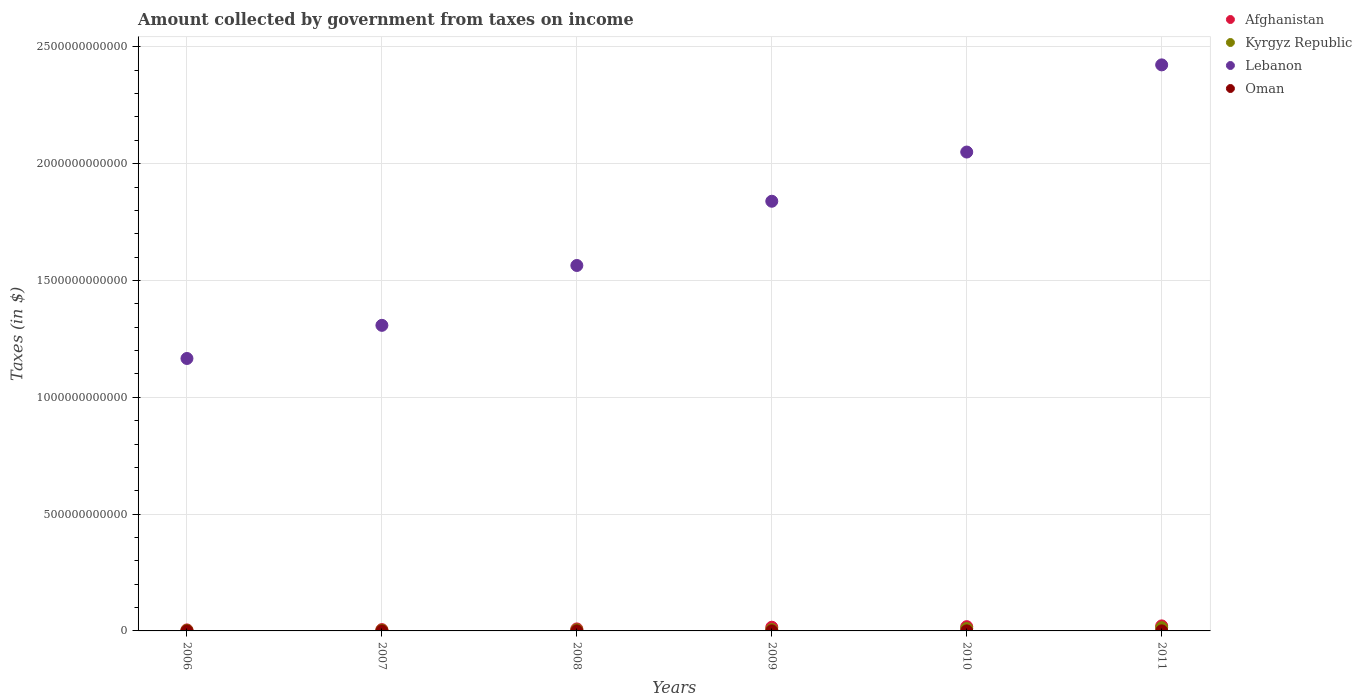How many different coloured dotlines are there?
Ensure brevity in your answer.  4. Is the number of dotlines equal to the number of legend labels?
Keep it short and to the point. Yes. What is the amount collected by government from taxes on income in Lebanon in 2006?
Ensure brevity in your answer.  1.17e+12. Across all years, what is the maximum amount collected by government from taxes on income in Oman?
Provide a short and direct response. 3.70e+08. Across all years, what is the minimum amount collected by government from taxes on income in Kyrgyz Republic?
Provide a succinct answer. 2.28e+09. In which year was the amount collected by government from taxes on income in Lebanon maximum?
Offer a very short reply. 2011. What is the total amount collected by government from taxes on income in Lebanon in the graph?
Offer a terse response. 1.04e+13. What is the difference between the amount collected by government from taxes on income in Afghanistan in 2009 and that in 2011?
Provide a short and direct response. -5.68e+09. What is the difference between the amount collected by government from taxes on income in Lebanon in 2010 and the amount collected by government from taxes on income in Kyrgyz Republic in 2009?
Ensure brevity in your answer.  2.04e+12. What is the average amount collected by government from taxes on income in Oman per year?
Offer a very short reply. 2.39e+08. In the year 2008, what is the difference between the amount collected by government from taxes on income in Kyrgyz Republic and amount collected by government from taxes on income in Lebanon?
Give a very brief answer. -1.56e+12. In how many years, is the amount collected by government from taxes on income in Afghanistan greater than 700000000000 $?
Your response must be concise. 0. What is the ratio of the amount collected by government from taxes on income in Oman in 2006 to that in 2011?
Provide a succinct answer. 0.3. Is the amount collected by government from taxes on income in Lebanon in 2006 less than that in 2011?
Provide a short and direct response. Yes. Is the difference between the amount collected by government from taxes on income in Kyrgyz Republic in 2007 and 2010 greater than the difference between the amount collected by government from taxes on income in Lebanon in 2007 and 2010?
Offer a very short reply. Yes. What is the difference between the highest and the second highest amount collected by government from taxes on income in Lebanon?
Keep it short and to the point. 3.73e+11. What is the difference between the highest and the lowest amount collected by government from taxes on income in Lebanon?
Make the answer very short. 1.26e+12. Is it the case that in every year, the sum of the amount collected by government from taxes on income in Lebanon and amount collected by government from taxes on income in Afghanistan  is greater than the sum of amount collected by government from taxes on income in Oman and amount collected by government from taxes on income in Kyrgyz Republic?
Your answer should be compact. No. Is it the case that in every year, the sum of the amount collected by government from taxes on income in Oman and amount collected by government from taxes on income in Kyrgyz Republic  is greater than the amount collected by government from taxes on income in Afghanistan?
Make the answer very short. No. Is the amount collected by government from taxes on income in Afghanistan strictly greater than the amount collected by government from taxes on income in Oman over the years?
Your response must be concise. Yes. How many dotlines are there?
Ensure brevity in your answer.  4. What is the difference between two consecutive major ticks on the Y-axis?
Offer a very short reply. 5.00e+11. How many legend labels are there?
Provide a succinct answer. 4. What is the title of the graph?
Offer a terse response. Amount collected by government from taxes on income. Does "Monaco" appear as one of the legend labels in the graph?
Provide a short and direct response. No. What is the label or title of the X-axis?
Your answer should be compact. Years. What is the label or title of the Y-axis?
Provide a short and direct response. Taxes (in $). What is the Taxes (in $) of Afghanistan in 2006?
Give a very brief answer. 4.36e+09. What is the Taxes (in $) of Kyrgyz Republic in 2006?
Give a very brief answer. 2.28e+09. What is the Taxes (in $) of Lebanon in 2006?
Give a very brief answer. 1.17e+12. What is the Taxes (in $) in Oman in 2006?
Make the answer very short. 8.54e+07. What is the Taxes (in $) in Afghanistan in 2007?
Make the answer very short. 5.64e+09. What is the Taxes (in $) in Kyrgyz Republic in 2007?
Offer a very short reply. 3.04e+09. What is the Taxes (in $) of Lebanon in 2007?
Provide a succinct answer. 1.31e+12. What is the Taxes (in $) in Oman in 2007?
Your answer should be compact. 1.87e+08. What is the Taxes (in $) of Afghanistan in 2008?
Your answer should be very brief. 8.62e+09. What is the Taxes (in $) of Kyrgyz Republic in 2008?
Make the answer very short. 4.61e+09. What is the Taxes (in $) in Lebanon in 2008?
Make the answer very short. 1.56e+12. What is the Taxes (in $) of Oman in 2008?
Ensure brevity in your answer.  2.37e+08. What is the Taxes (in $) of Afghanistan in 2009?
Ensure brevity in your answer.  1.58e+1. What is the Taxes (in $) in Kyrgyz Republic in 2009?
Offer a terse response. 5.75e+09. What is the Taxes (in $) in Lebanon in 2009?
Your answer should be very brief. 1.84e+12. What is the Taxes (in $) of Oman in 2009?
Provide a succinct answer. 3.70e+08. What is the Taxes (in $) in Afghanistan in 2010?
Your answer should be very brief. 1.82e+1. What is the Taxes (in $) in Kyrgyz Republic in 2010?
Your response must be concise. 1.04e+1. What is the Taxes (in $) of Lebanon in 2010?
Give a very brief answer. 2.05e+12. What is the Taxes (in $) in Oman in 2010?
Your answer should be compact. 2.73e+08. What is the Taxes (in $) of Afghanistan in 2011?
Provide a succinct answer. 2.15e+1. What is the Taxes (in $) of Kyrgyz Republic in 2011?
Keep it short and to the point. 1.40e+1. What is the Taxes (in $) in Lebanon in 2011?
Offer a terse response. 2.42e+12. What is the Taxes (in $) of Oman in 2011?
Make the answer very short. 2.82e+08. Across all years, what is the maximum Taxes (in $) of Afghanistan?
Ensure brevity in your answer.  2.15e+1. Across all years, what is the maximum Taxes (in $) of Kyrgyz Republic?
Your response must be concise. 1.40e+1. Across all years, what is the maximum Taxes (in $) of Lebanon?
Give a very brief answer. 2.42e+12. Across all years, what is the maximum Taxes (in $) of Oman?
Provide a succinct answer. 3.70e+08. Across all years, what is the minimum Taxes (in $) in Afghanistan?
Offer a very short reply. 4.36e+09. Across all years, what is the minimum Taxes (in $) of Kyrgyz Republic?
Offer a terse response. 2.28e+09. Across all years, what is the minimum Taxes (in $) in Lebanon?
Provide a short and direct response. 1.17e+12. Across all years, what is the minimum Taxes (in $) of Oman?
Give a very brief answer. 8.54e+07. What is the total Taxes (in $) in Afghanistan in the graph?
Make the answer very short. 7.42e+1. What is the total Taxes (in $) in Kyrgyz Republic in the graph?
Ensure brevity in your answer.  4.01e+1. What is the total Taxes (in $) of Lebanon in the graph?
Offer a terse response. 1.04e+13. What is the total Taxes (in $) in Oman in the graph?
Keep it short and to the point. 1.43e+09. What is the difference between the Taxes (in $) of Afghanistan in 2006 and that in 2007?
Your response must be concise. -1.28e+09. What is the difference between the Taxes (in $) in Kyrgyz Republic in 2006 and that in 2007?
Give a very brief answer. -7.61e+08. What is the difference between the Taxes (in $) in Lebanon in 2006 and that in 2007?
Make the answer very short. -1.42e+11. What is the difference between the Taxes (in $) of Oman in 2006 and that in 2007?
Provide a succinct answer. -1.02e+08. What is the difference between the Taxes (in $) of Afghanistan in 2006 and that in 2008?
Offer a very short reply. -4.25e+09. What is the difference between the Taxes (in $) of Kyrgyz Republic in 2006 and that in 2008?
Provide a short and direct response. -2.34e+09. What is the difference between the Taxes (in $) in Lebanon in 2006 and that in 2008?
Your answer should be compact. -3.98e+11. What is the difference between the Taxes (in $) of Oman in 2006 and that in 2008?
Your answer should be compact. -1.52e+08. What is the difference between the Taxes (in $) of Afghanistan in 2006 and that in 2009?
Ensure brevity in your answer.  -1.15e+1. What is the difference between the Taxes (in $) of Kyrgyz Republic in 2006 and that in 2009?
Keep it short and to the point. -3.47e+09. What is the difference between the Taxes (in $) in Lebanon in 2006 and that in 2009?
Provide a short and direct response. -6.73e+11. What is the difference between the Taxes (in $) of Oman in 2006 and that in 2009?
Provide a short and direct response. -2.85e+08. What is the difference between the Taxes (in $) of Afghanistan in 2006 and that in 2010?
Provide a succinct answer. -1.39e+1. What is the difference between the Taxes (in $) in Kyrgyz Republic in 2006 and that in 2010?
Make the answer very short. -8.11e+09. What is the difference between the Taxes (in $) of Lebanon in 2006 and that in 2010?
Your response must be concise. -8.84e+11. What is the difference between the Taxes (in $) of Oman in 2006 and that in 2010?
Ensure brevity in your answer.  -1.87e+08. What is the difference between the Taxes (in $) in Afghanistan in 2006 and that in 2011?
Offer a very short reply. -1.72e+1. What is the difference between the Taxes (in $) in Kyrgyz Republic in 2006 and that in 2011?
Give a very brief answer. -1.17e+1. What is the difference between the Taxes (in $) in Lebanon in 2006 and that in 2011?
Provide a short and direct response. -1.26e+12. What is the difference between the Taxes (in $) in Oman in 2006 and that in 2011?
Offer a terse response. -1.96e+08. What is the difference between the Taxes (in $) in Afghanistan in 2007 and that in 2008?
Give a very brief answer. -2.97e+09. What is the difference between the Taxes (in $) of Kyrgyz Republic in 2007 and that in 2008?
Your answer should be very brief. -1.57e+09. What is the difference between the Taxes (in $) of Lebanon in 2007 and that in 2008?
Provide a succinct answer. -2.56e+11. What is the difference between the Taxes (in $) of Oman in 2007 and that in 2008?
Your response must be concise. -5.03e+07. What is the difference between the Taxes (in $) of Afghanistan in 2007 and that in 2009?
Your answer should be very brief. -1.02e+1. What is the difference between the Taxes (in $) in Kyrgyz Republic in 2007 and that in 2009?
Make the answer very short. -2.71e+09. What is the difference between the Taxes (in $) in Lebanon in 2007 and that in 2009?
Keep it short and to the point. -5.31e+11. What is the difference between the Taxes (in $) of Oman in 2007 and that in 2009?
Provide a succinct answer. -1.83e+08. What is the difference between the Taxes (in $) of Afghanistan in 2007 and that in 2010?
Your response must be concise. -1.26e+1. What is the difference between the Taxes (in $) of Kyrgyz Republic in 2007 and that in 2010?
Your answer should be compact. -7.35e+09. What is the difference between the Taxes (in $) in Lebanon in 2007 and that in 2010?
Keep it short and to the point. -7.42e+11. What is the difference between the Taxes (in $) of Oman in 2007 and that in 2010?
Provide a short and direct response. -8.55e+07. What is the difference between the Taxes (in $) of Afghanistan in 2007 and that in 2011?
Keep it short and to the point. -1.59e+1. What is the difference between the Taxes (in $) of Kyrgyz Republic in 2007 and that in 2011?
Ensure brevity in your answer.  -1.09e+1. What is the difference between the Taxes (in $) of Lebanon in 2007 and that in 2011?
Your response must be concise. -1.11e+12. What is the difference between the Taxes (in $) of Oman in 2007 and that in 2011?
Keep it short and to the point. -9.48e+07. What is the difference between the Taxes (in $) in Afghanistan in 2008 and that in 2009?
Keep it short and to the point. -7.23e+09. What is the difference between the Taxes (in $) of Kyrgyz Republic in 2008 and that in 2009?
Provide a short and direct response. -1.14e+09. What is the difference between the Taxes (in $) in Lebanon in 2008 and that in 2009?
Give a very brief answer. -2.75e+11. What is the difference between the Taxes (in $) in Oman in 2008 and that in 2009?
Offer a terse response. -1.33e+08. What is the difference between the Taxes (in $) in Afghanistan in 2008 and that in 2010?
Offer a very short reply. -9.63e+09. What is the difference between the Taxes (in $) of Kyrgyz Republic in 2008 and that in 2010?
Your answer should be very brief. -5.77e+09. What is the difference between the Taxes (in $) in Lebanon in 2008 and that in 2010?
Offer a very short reply. -4.86e+11. What is the difference between the Taxes (in $) in Oman in 2008 and that in 2010?
Provide a short and direct response. -3.52e+07. What is the difference between the Taxes (in $) of Afghanistan in 2008 and that in 2011?
Provide a short and direct response. -1.29e+1. What is the difference between the Taxes (in $) in Kyrgyz Republic in 2008 and that in 2011?
Keep it short and to the point. -9.36e+09. What is the difference between the Taxes (in $) of Lebanon in 2008 and that in 2011?
Keep it short and to the point. -8.59e+11. What is the difference between the Taxes (in $) in Oman in 2008 and that in 2011?
Ensure brevity in your answer.  -4.45e+07. What is the difference between the Taxes (in $) of Afghanistan in 2009 and that in 2010?
Offer a very short reply. -2.41e+09. What is the difference between the Taxes (in $) in Kyrgyz Republic in 2009 and that in 2010?
Offer a terse response. -4.63e+09. What is the difference between the Taxes (in $) in Lebanon in 2009 and that in 2010?
Provide a short and direct response. -2.11e+11. What is the difference between the Taxes (in $) of Oman in 2009 and that in 2010?
Give a very brief answer. 9.75e+07. What is the difference between the Taxes (in $) of Afghanistan in 2009 and that in 2011?
Your answer should be very brief. -5.68e+09. What is the difference between the Taxes (in $) in Kyrgyz Republic in 2009 and that in 2011?
Your answer should be very brief. -8.23e+09. What is the difference between the Taxes (in $) of Lebanon in 2009 and that in 2011?
Make the answer very short. -5.84e+11. What is the difference between the Taxes (in $) of Oman in 2009 and that in 2011?
Offer a very short reply. 8.82e+07. What is the difference between the Taxes (in $) of Afghanistan in 2010 and that in 2011?
Ensure brevity in your answer.  -3.27e+09. What is the difference between the Taxes (in $) of Kyrgyz Republic in 2010 and that in 2011?
Provide a succinct answer. -3.59e+09. What is the difference between the Taxes (in $) in Lebanon in 2010 and that in 2011?
Give a very brief answer. -3.73e+11. What is the difference between the Taxes (in $) in Oman in 2010 and that in 2011?
Offer a terse response. -9.30e+06. What is the difference between the Taxes (in $) of Afghanistan in 2006 and the Taxes (in $) of Kyrgyz Republic in 2007?
Offer a terse response. 1.32e+09. What is the difference between the Taxes (in $) in Afghanistan in 2006 and the Taxes (in $) in Lebanon in 2007?
Keep it short and to the point. -1.30e+12. What is the difference between the Taxes (in $) in Afghanistan in 2006 and the Taxes (in $) in Oman in 2007?
Your answer should be compact. 4.17e+09. What is the difference between the Taxes (in $) of Kyrgyz Republic in 2006 and the Taxes (in $) of Lebanon in 2007?
Offer a very short reply. -1.31e+12. What is the difference between the Taxes (in $) of Kyrgyz Republic in 2006 and the Taxes (in $) of Oman in 2007?
Provide a succinct answer. 2.09e+09. What is the difference between the Taxes (in $) in Lebanon in 2006 and the Taxes (in $) in Oman in 2007?
Keep it short and to the point. 1.17e+12. What is the difference between the Taxes (in $) of Afghanistan in 2006 and the Taxes (in $) of Kyrgyz Republic in 2008?
Offer a very short reply. -2.54e+08. What is the difference between the Taxes (in $) in Afghanistan in 2006 and the Taxes (in $) in Lebanon in 2008?
Provide a succinct answer. -1.56e+12. What is the difference between the Taxes (in $) in Afghanistan in 2006 and the Taxes (in $) in Oman in 2008?
Offer a terse response. 4.12e+09. What is the difference between the Taxes (in $) in Kyrgyz Republic in 2006 and the Taxes (in $) in Lebanon in 2008?
Offer a terse response. -1.56e+12. What is the difference between the Taxes (in $) of Kyrgyz Republic in 2006 and the Taxes (in $) of Oman in 2008?
Your answer should be compact. 2.04e+09. What is the difference between the Taxes (in $) in Lebanon in 2006 and the Taxes (in $) in Oman in 2008?
Your answer should be very brief. 1.17e+12. What is the difference between the Taxes (in $) in Afghanistan in 2006 and the Taxes (in $) in Kyrgyz Republic in 2009?
Provide a short and direct response. -1.39e+09. What is the difference between the Taxes (in $) of Afghanistan in 2006 and the Taxes (in $) of Lebanon in 2009?
Keep it short and to the point. -1.83e+12. What is the difference between the Taxes (in $) in Afghanistan in 2006 and the Taxes (in $) in Oman in 2009?
Keep it short and to the point. 3.99e+09. What is the difference between the Taxes (in $) in Kyrgyz Republic in 2006 and the Taxes (in $) in Lebanon in 2009?
Provide a short and direct response. -1.84e+12. What is the difference between the Taxes (in $) in Kyrgyz Republic in 2006 and the Taxes (in $) in Oman in 2009?
Your response must be concise. 1.91e+09. What is the difference between the Taxes (in $) of Lebanon in 2006 and the Taxes (in $) of Oman in 2009?
Offer a terse response. 1.17e+12. What is the difference between the Taxes (in $) of Afghanistan in 2006 and the Taxes (in $) of Kyrgyz Republic in 2010?
Offer a very short reply. -6.02e+09. What is the difference between the Taxes (in $) in Afghanistan in 2006 and the Taxes (in $) in Lebanon in 2010?
Your answer should be very brief. -2.05e+12. What is the difference between the Taxes (in $) in Afghanistan in 2006 and the Taxes (in $) in Oman in 2010?
Ensure brevity in your answer.  4.09e+09. What is the difference between the Taxes (in $) of Kyrgyz Republic in 2006 and the Taxes (in $) of Lebanon in 2010?
Give a very brief answer. -2.05e+12. What is the difference between the Taxes (in $) of Kyrgyz Republic in 2006 and the Taxes (in $) of Oman in 2010?
Ensure brevity in your answer.  2.01e+09. What is the difference between the Taxes (in $) in Lebanon in 2006 and the Taxes (in $) in Oman in 2010?
Your answer should be very brief. 1.17e+12. What is the difference between the Taxes (in $) in Afghanistan in 2006 and the Taxes (in $) in Kyrgyz Republic in 2011?
Keep it short and to the point. -9.62e+09. What is the difference between the Taxes (in $) in Afghanistan in 2006 and the Taxes (in $) in Lebanon in 2011?
Your answer should be very brief. -2.42e+12. What is the difference between the Taxes (in $) of Afghanistan in 2006 and the Taxes (in $) of Oman in 2011?
Keep it short and to the point. 4.08e+09. What is the difference between the Taxes (in $) of Kyrgyz Republic in 2006 and the Taxes (in $) of Lebanon in 2011?
Offer a very short reply. -2.42e+12. What is the difference between the Taxes (in $) in Kyrgyz Republic in 2006 and the Taxes (in $) in Oman in 2011?
Provide a succinct answer. 2.00e+09. What is the difference between the Taxes (in $) of Lebanon in 2006 and the Taxes (in $) of Oman in 2011?
Offer a terse response. 1.17e+12. What is the difference between the Taxes (in $) of Afghanistan in 2007 and the Taxes (in $) of Kyrgyz Republic in 2008?
Give a very brief answer. 1.03e+09. What is the difference between the Taxes (in $) of Afghanistan in 2007 and the Taxes (in $) of Lebanon in 2008?
Your answer should be compact. -1.56e+12. What is the difference between the Taxes (in $) of Afghanistan in 2007 and the Taxes (in $) of Oman in 2008?
Keep it short and to the point. 5.41e+09. What is the difference between the Taxes (in $) of Kyrgyz Republic in 2007 and the Taxes (in $) of Lebanon in 2008?
Provide a short and direct response. -1.56e+12. What is the difference between the Taxes (in $) of Kyrgyz Republic in 2007 and the Taxes (in $) of Oman in 2008?
Provide a succinct answer. 2.80e+09. What is the difference between the Taxes (in $) of Lebanon in 2007 and the Taxes (in $) of Oman in 2008?
Your response must be concise. 1.31e+12. What is the difference between the Taxes (in $) of Afghanistan in 2007 and the Taxes (in $) of Kyrgyz Republic in 2009?
Ensure brevity in your answer.  -1.07e+08. What is the difference between the Taxes (in $) of Afghanistan in 2007 and the Taxes (in $) of Lebanon in 2009?
Offer a terse response. -1.83e+12. What is the difference between the Taxes (in $) of Afghanistan in 2007 and the Taxes (in $) of Oman in 2009?
Your answer should be very brief. 5.27e+09. What is the difference between the Taxes (in $) in Kyrgyz Republic in 2007 and the Taxes (in $) in Lebanon in 2009?
Offer a very short reply. -1.84e+12. What is the difference between the Taxes (in $) in Kyrgyz Republic in 2007 and the Taxes (in $) in Oman in 2009?
Make the answer very short. 2.67e+09. What is the difference between the Taxes (in $) in Lebanon in 2007 and the Taxes (in $) in Oman in 2009?
Your answer should be very brief. 1.31e+12. What is the difference between the Taxes (in $) in Afghanistan in 2007 and the Taxes (in $) in Kyrgyz Republic in 2010?
Your response must be concise. -4.74e+09. What is the difference between the Taxes (in $) of Afghanistan in 2007 and the Taxes (in $) of Lebanon in 2010?
Offer a terse response. -2.04e+12. What is the difference between the Taxes (in $) in Afghanistan in 2007 and the Taxes (in $) in Oman in 2010?
Make the answer very short. 5.37e+09. What is the difference between the Taxes (in $) in Kyrgyz Republic in 2007 and the Taxes (in $) in Lebanon in 2010?
Give a very brief answer. -2.05e+12. What is the difference between the Taxes (in $) of Kyrgyz Republic in 2007 and the Taxes (in $) of Oman in 2010?
Your answer should be compact. 2.77e+09. What is the difference between the Taxes (in $) in Lebanon in 2007 and the Taxes (in $) in Oman in 2010?
Your response must be concise. 1.31e+12. What is the difference between the Taxes (in $) of Afghanistan in 2007 and the Taxes (in $) of Kyrgyz Republic in 2011?
Your response must be concise. -8.33e+09. What is the difference between the Taxes (in $) of Afghanistan in 2007 and the Taxes (in $) of Lebanon in 2011?
Your response must be concise. -2.42e+12. What is the difference between the Taxes (in $) in Afghanistan in 2007 and the Taxes (in $) in Oman in 2011?
Offer a very short reply. 5.36e+09. What is the difference between the Taxes (in $) in Kyrgyz Republic in 2007 and the Taxes (in $) in Lebanon in 2011?
Provide a succinct answer. -2.42e+12. What is the difference between the Taxes (in $) of Kyrgyz Republic in 2007 and the Taxes (in $) of Oman in 2011?
Offer a very short reply. 2.76e+09. What is the difference between the Taxes (in $) of Lebanon in 2007 and the Taxes (in $) of Oman in 2011?
Your response must be concise. 1.31e+12. What is the difference between the Taxes (in $) in Afghanistan in 2008 and the Taxes (in $) in Kyrgyz Republic in 2009?
Keep it short and to the point. 2.86e+09. What is the difference between the Taxes (in $) of Afghanistan in 2008 and the Taxes (in $) of Lebanon in 2009?
Offer a very short reply. -1.83e+12. What is the difference between the Taxes (in $) of Afghanistan in 2008 and the Taxes (in $) of Oman in 2009?
Offer a terse response. 8.24e+09. What is the difference between the Taxes (in $) in Kyrgyz Republic in 2008 and the Taxes (in $) in Lebanon in 2009?
Make the answer very short. -1.83e+12. What is the difference between the Taxes (in $) in Kyrgyz Republic in 2008 and the Taxes (in $) in Oman in 2009?
Your answer should be very brief. 4.24e+09. What is the difference between the Taxes (in $) in Lebanon in 2008 and the Taxes (in $) in Oman in 2009?
Make the answer very short. 1.56e+12. What is the difference between the Taxes (in $) of Afghanistan in 2008 and the Taxes (in $) of Kyrgyz Republic in 2010?
Make the answer very short. -1.77e+09. What is the difference between the Taxes (in $) in Afghanistan in 2008 and the Taxes (in $) in Lebanon in 2010?
Make the answer very short. -2.04e+12. What is the difference between the Taxes (in $) of Afghanistan in 2008 and the Taxes (in $) of Oman in 2010?
Keep it short and to the point. 8.34e+09. What is the difference between the Taxes (in $) of Kyrgyz Republic in 2008 and the Taxes (in $) of Lebanon in 2010?
Your answer should be compact. -2.05e+12. What is the difference between the Taxes (in $) in Kyrgyz Republic in 2008 and the Taxes (in $) in Oman in 2010?
Provide a short and direct response. 4.34e+09. What is the difference between the Taxes (in $) in Lebanon in 2008 and the Taxes (in $) in Oman in 2010?
Ensure brevity in your answer.  1.56e+12. What is the difference between the Taxes (in $) of Afghanistan in 2008 and the Taxes (in $) of Kyrgyz Republic in 2011?
Your answer should be compact. -5.36e+09. What is the difference between the Taxes (in $) in Afghanistan in 2008 and the Taxes (in $) in Lebanon in 2011?
Keep it short and to the point. -2.41e+12. What is the difference between the Taxes (in $) in Afghanistan in 2008 and the Taxes (in $) in Oman in 2011?
Make the answer very short. 8.33e+09. What is the difference between the Taxes (in $) in Kyrgyz Republic in 2008 and the Taxes (in $) in Lebanon in 2011?
Provide a succinct answer. -2.42e+12. What is the difference between the Taxes (in $) of Kyrgyz Republic in 2008 and the Taxes (in $) of Oman in 2011?
Give a very brief answer. 4.33e+09. What is the difference between the Taxes (in $) in Lebanon in 2008 and the Taxes (in $) in Oman in 2011?
Offer a terse response. 1.56e+12. What is the difference between the Taxes (in $) in Afghanistan in 2009 and the Taxes (in $) in Kyrgyz Republic in 2010?
Provide a short and direct response. 5.45e+09. What is the difference between the Taxes (in $) in Afghanistan in 2009 and the Taxes (in $) in Lebanon in 2010?
Offer a terse response. -2.03e+12. What is the difference between the Taxes (in $) of Afghanistan in 2009 and the Taxes (in $) of Oman in 2010?
Keep it short and to the point. 1.56e+1. What is the difference between the Taxes (in $) of Kyrgyz Republic in 2009 and the Taxes (in $) of Lebanon in 2010?
Your answer should be compact. -2.04e+12. What is the difference between the Taxes (in $) of Kyrgyz Republic in 2009 and the Taxes (in $) of Oman in 2010?
Offer a terse response. 5.48e+09. What is the difference between the Taxes (in $) of Lebanon in 2009 and the Taxes (in $) of Oman in 2010?
Your answer should be compact. 1.84e+12. What is the difference between the Taxes (in $) of Afghanistan in 2009 and the Taxes (in $) of Kyrgyz Republic in 2011?
Offer a very short reply. 1.86e+09. What is the difference between the Taxes (in $) in Afghanistan in 2009 and the Taxes (in $) in Lebanon in 2011?
Ensure brevity in your answer.  -2.41e+12. What is the difference between the Taxes (in $) of Afghanistan in 2009 and the Taxes (in $) of Oman in 2011?
Provide a short and direct response. 1.56e+1. What is the difference between the Taxes (in $) of Kyrgyz Republic in 2009 and the Taxes (in $) of Lebanon in 2011?
Ensure brevity in your answer.  -2.42e+12. What is the difference between the Taxes (in $) in Kyrgyz Republic in 2009 and the Taxes (in $) in Oman in 2011?
Keep it short and to the point. 5.47e+09. What is the difference between the Taxes (in $) of Lebanon in 2009 and the Taxes (in $) of Oman in 2011?
Give a very brief answer. 1.84e+12. What is the difference between the Taxes (in $) in Afghanistan in 2010 and the Taxes (in $) in Kyrgyz Republic in 2011?
Your response must be concise. 4.27e+09. What is the difference between the Taxes (in $) in Afghanistan in 2010 and the Taxes (in $) in Lebanon in 2011?
Keep it short and to the point. -2.40e+12. What is the difference between the Taxes (in $) of Afghanistan in 2010 and the Taxes (in $) of Oman in 2011?
Make the answer very short. 1.80e+1. What is the difference between the Taxes (in $) in Kyrgyz Republic in 2010 and the Taxes (in $) in Lebanon in 2011?
Offer a very short reply. -2.41e+12. What is the difference between the Taxes (in $) of Kyrgyz Republic in 2010 and the Taxes (in $) of Oman in 2011?
Offer a very short reply. 1.01e+1. What is the difference between the Taxes (in $) of Lebanon in 2010 and the Taxes (in $) of Oman in 2011?
Your response must be concise. 2.05e+12. What is the average Taxes (in $) of Afghanistan per year?
Your answer should be very brief. 1.24e+1. What is the average Taxes (in $) of Kyrgyz Republic per year?
Give a very brief answer. 6.68e+09. What is the average Taxes (in $) of Lebanon per year?
Keep it short and to the point. 1.73e+12. What is the average Taxes (in $) of Oman per year?
Offer a terse response. 2.39e+08. In the year 2006, what is the difference between the Taxes (in $) in Afghanistan and Taxes (in $) in Kyrgyz Republic?
Offer a very short reply. 2.08e+09. In the year 2006, what is the difference between the Taxes (in $) of Afghanistan and Taxes (in $) of Lebanon?
Offer a terse response. -1.16e+12. In the year 2006, what is the difference between the Taxes (in $) of Afghanistan and Taxes (in $) of Oman?
Your answer should be compact. 4.28e+09. In the year 2006, what is the difference between the Taxes (in $) in Kyrgyz Republic and Taxes (in $) in Lebanon?
Ensure brevity in your answer.  -1.16e+12. In the year 2006, what is the difference between the Taxes (in $) of Kyrgyz Republic and Taxes (in $) of Oman?
Offer a very short reply. 2.19e+09. In the year 2006, what is the difference between the Taxes (in $) of Lebanon and Taxes (in $) of Oman?
Give a very brief answer. 1.17e+12. In the year 2007, what is the difference between the Taxes (in $) of Afghanistan and Taxes (in $) of Kyrgyz Republic?
Ensure brevity in your answer.  2.60e+09. In the year 2007, what is the difference between the Taxes (in $) in Afghanistan and Taxes (in $) in Lebanon?
Ensure brevity in your answer.  -1.30e+12. In the year 2007, what is the difference between the Taxes (in $) of Afghanistan and Taxes (in $) of Oman?
Keep it short and to the point. 5.46e+09. In the year 2007, what is the difference between the Taxes (in $) in Kyrgyz Republic and Taxes (in $) in Lebanon?
Your response must be concise. -1.30e+12. In the year 2007, what is the difference between the Taxes (in $) in Kyrgyz Republic and Taxes (in $) in Oman?
Offer a very short reply. 2.85e+09. In the year 2007, what is the difference between the Taxes (in $) of Lebanon and Taxes (in $) of Oman?
Give a very brief answer. 1.31e+12. In the year 2008, what is the difference between the Taxes (in $) of Afghanistan and Taxes (in $) of Kyrgyz Republic?
Offer a terse response. 4.00e+09. In the year 2008, what is the difference between the Taxes (in $) in Afghanistan and Taxes (in $) in Lebanon?
Ensure brevity in your answer.  -1.56e+12. In the year 2008, what is the difference between the Taxes (in $) of Afghanistan and Taxes (in $) of Oman?
Offer a terse response. 8.38e+09. In the year 2008, what is the difference between the Taxes (in $) in Kyrgyz Republic and Taxes (in $) in Lebanon?
Offer a very short reply. -1.56e+12. In the year 2008, what is the difference between the Taxes (in $) in Kyrgyz Republic and Taxes (in $) in Oman?
Offer a terse response. 4.38e+09. In the year 2008, what is the difference between the Taxes (in $) in Lebanon and Taxes (in $) in Oman?
Offer a very short reply. 1.56e+12. In the year 2009, what is the difference between the Taxes (in $) in Afghanistan and Taxes (in $) in Kyrgyz Republic?
Keep it short and to the point. 1.01e+1. In the year 2009, what is the difference between the Taxes (in $) of Afghanistan and Taxes (in $) of Lebanon?
Offer a terse response. -1.82e+12. In the year 2009, what is the difference between the Taxes (in $) in Afghanistan and Taxes (in $) in Oman?
Give a very brief answer. 1.55e+1. In the year 2009, what is the difference between the Taxes (in $) in Kyrgyz Republic and Taxes (in $) in Lebanon?
Make the answer very short. -1.83e+12. In the year 2009, what is the difference between the Taxes (in $) of Kyrgyz Republic and Taxes (in $) of Oman?
Your answer should be compact. 5.38e+09. In the year 2009, what is the difference between the Taxes (in $) in Lebanon and Taxes (in $) in Oman?
Provide a succinct answer. 1.84e+12. In the year 2010, what is the difference between the Taxes (in $) in Afghanistan and Taxes (in $) in Kyrgyz Republic?
Ensure brevity in your answer.  7.86e+09. In the year 2010, what is the difference between the Taxes (in $) in Afghanistan and Taxes (in $) in Lebanon?
Give a very brief answer. -2.03e+12. In the year 2010, what is the difference between the Taxes (in $) of Afghanistan and Taxes (in $) of Oman?
Your answer should be compact. 1.80e+1. In the year 2010, what is the difference between the Taxes (in $) of Kyrgyz Republic and Taxes (in $) of Lebanon?
Give a very brief answer. -2.04e+12. In the year 2010, what is the difference between the Taxes (in $) of Kyrgyz Republic and Taxes (in $) of Oman?
Your answer should be compact. 1.01e+1. In the year 2010, what is the difference between the Taxes (in $) in Lebanon and Taxes (in $) in Oman?
Ensure brevity in your answer.  2.05e+12. In the year 2011, what is the difference between the Taxes (in $) of Afghanistan and Taxes (in $) of Kyrgyz Republic?
Make the answer very short. 7.54e+09. In the year 2011, what is the difference between the Taxes (in $) in Afghanistan and Taxes (in $) in Lebanon?
Your response must be concise. -2.40e+12. In the year 2011, what is the difference between the Taxes (in $) of Afghanistan and Taxes (in $) of Oman?
Provide a short and direct response. 2.12e+1. In the year 2011, what is the difference between the Taxes (in $) in Kyrgyz Republic and Taxes (in $) in Lebanon?
Offer a terse response. -2.41e+12. In the year 2011, what is the difference between the Taxes (in $) in Kyrgyz Republic and Taxes (in $) in Oman?
Provide a succinct answer. 1.37e+1. In the year 2011, what is the difference between the Taxes (in $) of Lebanon and Taxes (in $) of Oman?
Keep it short and to the point. 2.42e+12. What is the ratio of the Taxes (in $) of Afghanistan in 2006 to that in 2007?
Your answer should be compact. 0.77. What is the ratio of the Taxes (in $) of Kyrgyz Republic in 2006 to that in 2007?
Offer a terse response. 0.75. What is the ratio of the Taxes (in $) in Lebanon in 2006 to that in 2007?
Ensure brevity in your answer.  0.89. What is the ratio of the Taxes (in $) in Oman in 2006 to that in 2007?
Offer a terse response. 0.46. What is the ratio of the Taxes (in $) of Afghanistan in 2006 to that in 2008?
Offer a very short reply. 0.51. What is the ratio of the Taxes (in $) of Kyrgyz Republic in 2006 to that in 2008?
Provide a succinct answer. 0.49. What is the ratio of the Taxes (in $) of Lebanon in 2006 to that in 2008?
Your answer should be very brief. 0.75. What is the ratio of the Taxes (in $) in Oman in 2006 to that in 2008?
Offer a terse response. 0.36. What is the ratio of the Taxes (in $) of Afghanistan in 2006 to that in 2009?
Offer a very short reply. 0.28. What is the ratio of the Taxes (in $) in Kyrgyz Republic in 2006 to that in 2009?
Keep it short and to the point. 0.4. What is the ratio of the Taxes (in $) of Lebanon in 2006 to that in 2009?
Give a very brief answer. 0.63. What is the ratio of the Taxes (in $) in Oman in 2006 to that in 2009?
Give a very brief answer. 0.23. What is the ratio of the Taxes (in $) of Afghanistan in 2006 to that in 2010?
Your answer should be very brief. 0.24. What is the ratio of the Taxes (in $) of Kyrgyz Republic in 2006 to that in 2010?
Your response must be concise. 0.22. What is the ratio of the Taxes (in $) of Lebanon in 2006 to that in 2010?
Make the answer very short. 0.57. What is the ratio of the Taxes (in $) in Oman in 2006 to that in 2010?
Your answer should be compact. 0.31. What is the ratio of the Taxes (in $) of Afghanistan in 2006 to that in 2011?
Ensure brevity in your answer.  0.2. What is the ratio of the Taxes (in $) of Kyrgyz Republic in 2006 to that in 2011?
Ensure brevity in your answer.  0.16. What is the ratio of the Taxes (in $) of Lebanon in 2006 to that in 2011?
Provide a succinct answer. 0.48. What is the ratio of the Taxes (in $) of Oman in 2006 to that in 2011?
Your answer should be very brief. 0.3. What is the ratio of the Taxes (in $) in Afghanistan in 2007 to that in 2008?
Ensure brevity in your answer.  0.66. What is the ratio of the Taxes (in $) of Kyrgyz Republic in 2007 to that in 2008?
Offer a very short reply. 0.66. What is the ratio of the Taxes (in $) of Lebanon in 2007 to that in 2008?
Your response must be concise. 0.84. What is the ratio of the Taxes (in $) in Oman in 2007 to that in 2008?
Keep it short and to the point. 0.79. What is the ratio of the Taxes (in $) of Afghanistan in 2007 to that in 2009?
Make the answer very short. 0.36. What is the ratio of the Taxes (in $) of Kyrgyz Republic in 2007 to that in 2009?
Provide a short and direct response. 0.53. What is the ratio of the Taxes (in $) in Lebanon in 2007 to that in 2009?
Make the answer very short. 0.71. What is the ratio of the Taxes (in $) in Oman in 2007 to that in 2009?
Your answer should be very brief. 0.51. What is the ratio of the Taxes (in $) in Afghanistan in 2007 to that in 2010?
Give a very brief answer. 0.31. What is the ratio of the Taxes (in $) in Kyrgyz Republic in 2007 to that in 2010?
Your response must be concise. 0.29. What is the ratio of the Taxes (in $) of Lebanon in 2007 to that in 2010?
Your answer should be compact. 0.64. What is the ratio of the Taxes (in $) of Oman in 2007 to that in 2010?
Offer a very short reply. 0.69. What is the ratio of the Taxes (in $) in Afghanistan in 2007 to that in 2011?
Provide a short and direct response. 0.26. What is the ratio of the Taxes (in $) in Kyrgyz Republic in 2007 to that in 2011?
Ensure brevity in your answer.  0.22. What is the ratio of the Taxes (in $) of Lebanon in 2007 to that in 2011?
Offer a terse response. 0.54. What is the ratio of the Taxes (in $) in Oman in 2007 to that in 2011?
Your answer should be very brief. 0.66. What is the ratio of the Taxes (in $) of Afghanistan in 2008 to that in 2009?
Ensure brevity in your answer.  0.54. What is the ratio of the Taxes (in $) in Kyrgyz Republic in 2008 to that in 2009?
Make the answer very short. 0.8. What is the ratio of the Taxes (in $) in Lebanon in 2008 to that in 2009?
Keep it short and to the point. 0.85. What is the ratio of the Taxes (in $) in Oman in 2008 to that in 2009?
Offer a terse response. 0.64. What is the ratio of the Taxes (in $) of Afghanistan in 2008 to that in 2010?
Give a very brief answer. 0.47. What is the ratio of the Taxes (in $) of Kyrgyz Republic in 2008 to that in 2010?
Your answer should be compact. 0.44. What is the ratio of the Taxes (in $) of Lebanon in 2008 to that in 2010?
Ensure brevity in your answer.  0.76. What is the ratio of the Taxes (in $) in Oman in 2008 to that in 2010?
Keep it short and to the point. 0.87. What is the ratio of the Taxes (in $) of Afghanistan in 2008 to that in 2011?
Your response must be concise. 0.4. What is the ratio of the Taxes (in $) in Kyrgyz Republic in 2008 to that in 2011?
Your answer should be very brief. 0.33. What is the ratio of the Taxes (in $) of Lebanon in 2008 to that in 2011?
Ensure brevity in your answer.  0.65. What is the ratio of the Taxes (in $) of Oman in 2008 to that in 2011?
Give a very brief answer. 0.84. What is the ratio of the Taxes (in $) of Afghanistan in 2009 to that in 2010?
Offer a terse response. 0.87. What is the ratio of the Taxes (in $) in Kyrgyz Republic in 2009 to that in 2010?
Offer a terse response. 0.55. What is the ratio of the Taxes (in $) in Lebanon in 2009 to that in 2010?
Make the answer very short. 0.9. What is the ratio of the Taxes (in $) in Oman in 2009 to that in 2010?
Offer a very short reply. 1.36. What is the ratio of the Taxes (in $) of Afghanistan in 2009 to that in 2011?
Provide a succinct answer. 0.74. What is the ratio of the Taxes (in $) in Kyrgyz Republic in 2009 to that in 2011?
Your answer should be compact. 0.41. What is the ratio of the Taxes (in $) of Lebanon in 2009 to that in 2011?
Your response must be concise. 0.76. What is the ratio of the Taxes (in $) in Oman in 2009 to that in 2011?
Give a very brief answer. 1.31. What is the ratio of the Taxes (in $) in Afghanistan in 2010 to that in 2011?
Provide a succinct answer. 0.85. What is the ratio of the Taxes (in $) in Kyrgyz Republic in 2010 to that in 2011?
Give a very brief answer. 0.74. What is the ratio of the Taxes (in $) of Lebanon in 2010 to that in 2011?
Keep it short and to the point. 0.85. What is the difference between the highest and the second highest Taxes (in $) of Afghanistan?
Make the answer very short. 3.27e+09. What is the difference between the highest and the second highest Taxes (in $) of Kyrgyz Republic?
Your answer should be compact. 3.59e+09. What is the difference between the highest and the second highest Taxes (in $) in Lebanon?
Your answer should be compact. 3.73e+11. What is the difference between the highest and the second highest Taxes (in $) in Oman?
Provide a succinct answer. 8.82e+07. What is the difference between the highest and the lowest Taxes (in $) of Afghanistan?
Offer a very short reply. 1.72e+1. What is the difference between the highest and the lowest Taxes (in $) in Kyrgyz Republic?
Provide a short and direct response. 1.17e+1. What is the difference between the highest and the lowest Taxes (in $) in Lebanon?
Offer a terse response. 1.26e+12. What is the difference between the highest and the lowest Taxes (in $) of Oman?
Make the answer very short. 2.85e+08. 